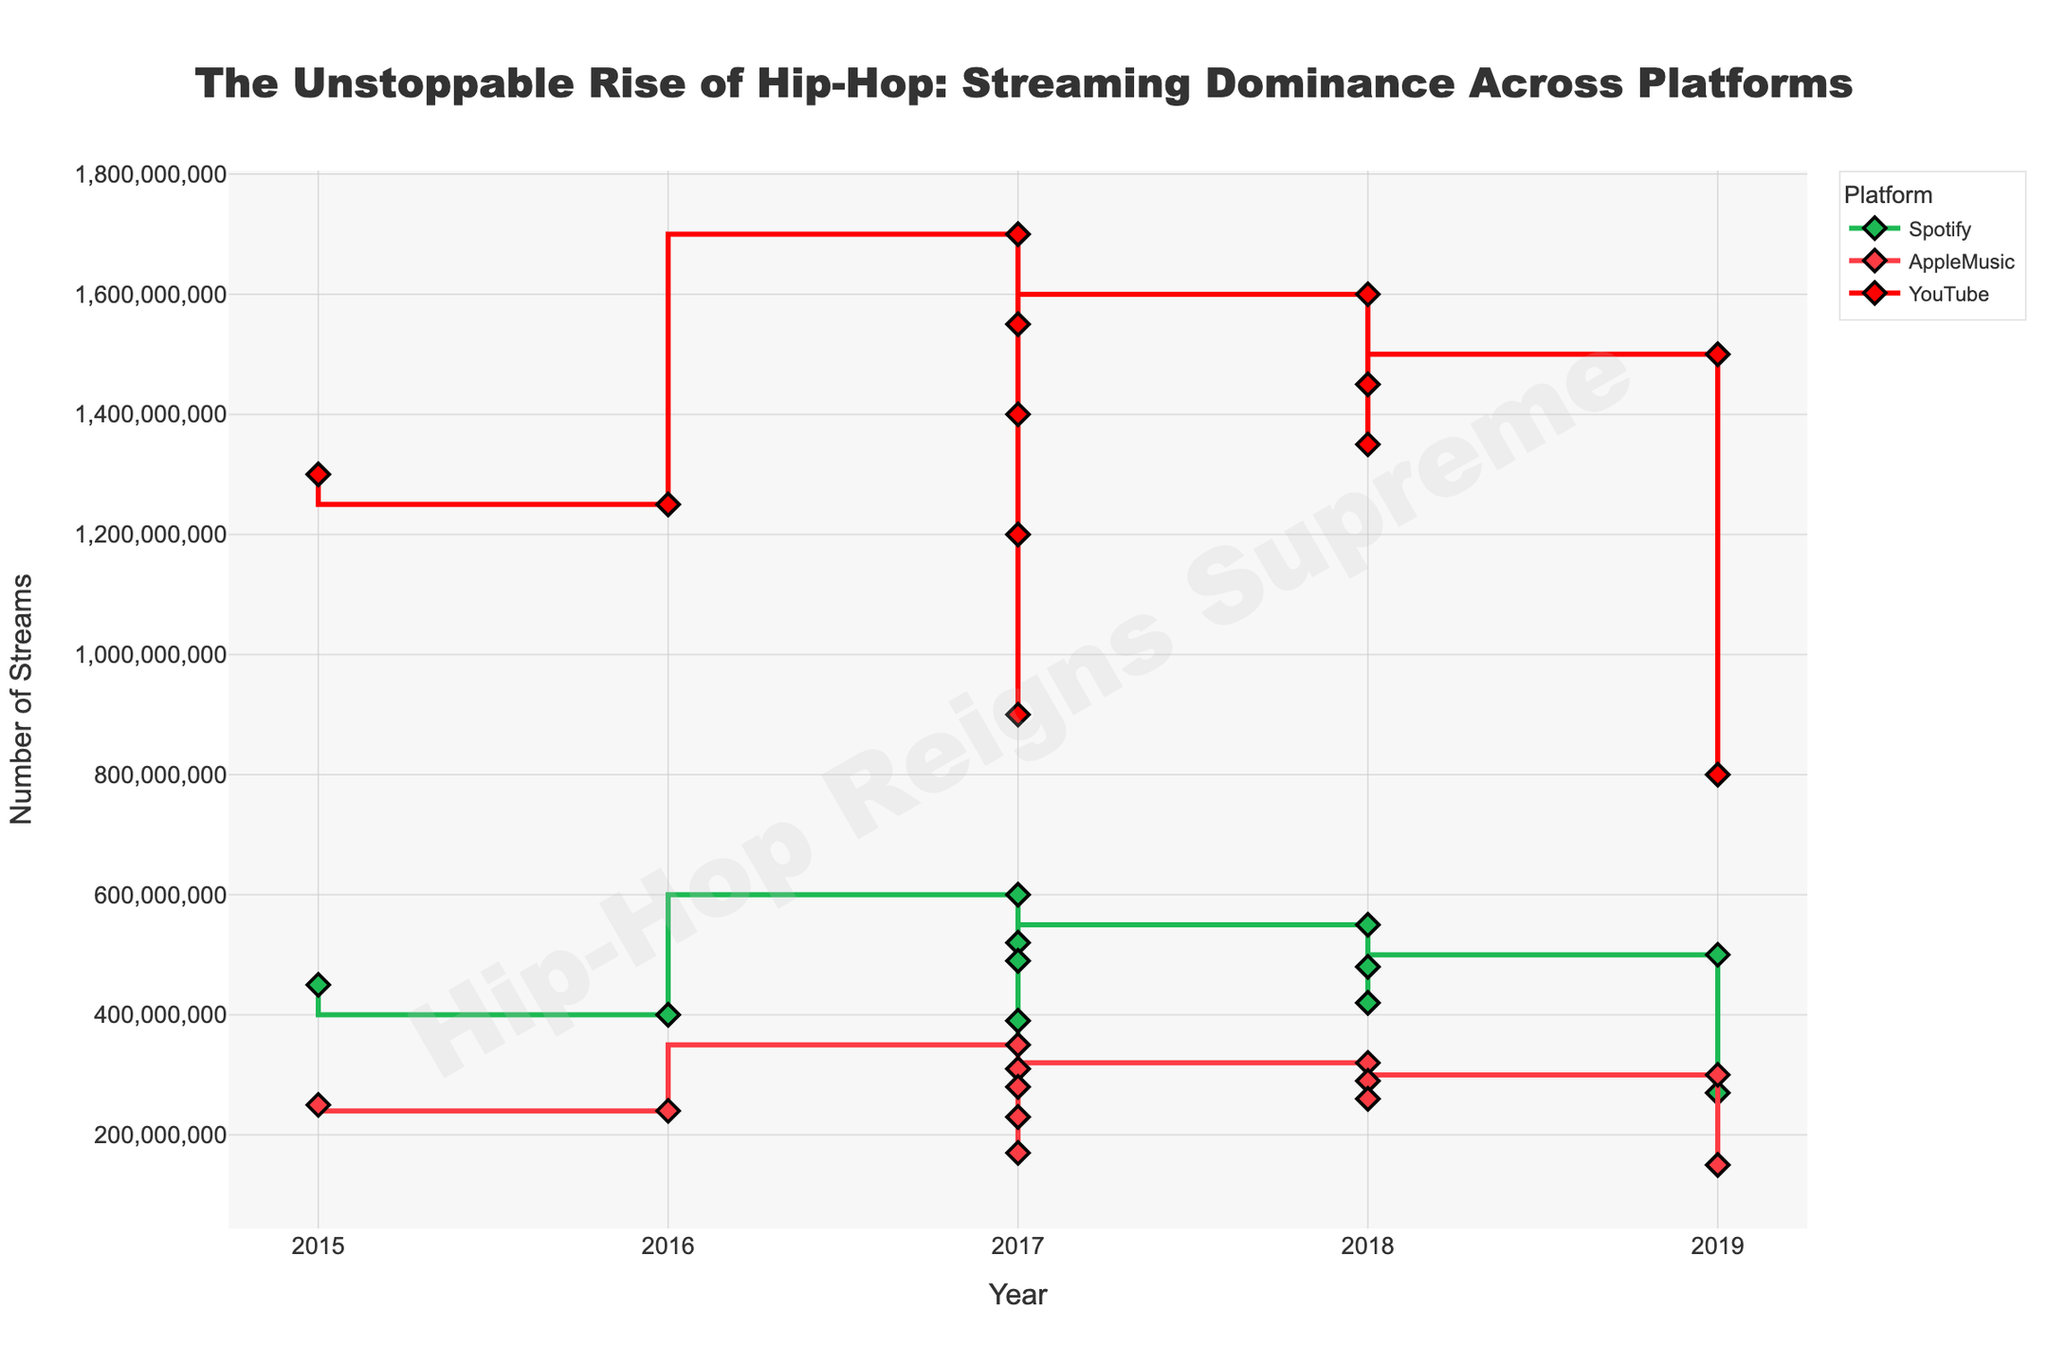What is the title of the figure? The title is usually displayed prominently at the top of the figure. In this case, it reads "The Unstoppable Rise of Hip-Hop: Streaming Dominance Across Platforms"
Answer: The Unstoppable Rise of Hip-Hop: Streaming Dominance Across Platforms Which platform has the highest number of streams for "Old Town Road"? By looking at the stair plot and checking the specific lines for "Old Town Road" across different platforms, we see that YouTube has the highest number of streams for this song.
Answer: YouTube How many platforms are represented in the figure? Observing the legend on the figure reveals three different platforms listed: Spotify, Apple Music, and YouTube.
Answer: Three Which year has the highest total number of streams across all platforms? Identify the year with the highest cumulative number of streams by summing up the streams across all platforms for each year. 2017 has multiple high-streaming singles. Adding them (Rockstar, HUMBLE., Bodak Yellow, Mask Off, XO TOUR Llif3) results in a very high total.
Answer: 2017 What is the trend of streams on Spotify over the years? To see the trend, follow the green line in the plot from left to right. The streams on Spotify appear to show a generally increasing trend over the years as more songs have higher streams in recent years.
Answer: Increasing Which song has the highest number of streams on Apple Music in 2017? Check the stair plot for Apple Music in 2017. Among the several singles displayed, "Rockstar" has the highest number of streams on Apple Music.
Answer: Rockstar What is the average number of YouTube streams for songs released in 2018? Sum the YouTube streams for songs released in 2018 (God's Plan, Sicko Mode, Lucid Dreams), which are 1,600,000,000 + 1,450,000,000 + 1,350,000,000 = 4,400,000,000, then divide by 3 to get the average.
Answer: 1,466,666,667 How does the popularity of "Rockstar" compare to "God's Plan" across different platforms? Compare the streams of "Rockstar" and "God's Plan" on each platform. "Rockstar" exceeds "God's Plan" on Spotify and Apple Music but is close on YouTube.
Answer: Higher on Spotify and Apple Music, similar on YouTube What is the overall trend of YouTube streams from 2015 to 2019? Trace the red line in the plot from 2015 to 2019. The streams on YouTube generally show an upward trend, peaking around 2018-2019.
Answer: Upward Which song released in 2019 has the lowest number of streams across all platforms? Look at the 2019 data points and find the song with the lowest streams. "Suge" by DaBaby has the lowest streams across all platforms in 2019.
Answer: Suge 